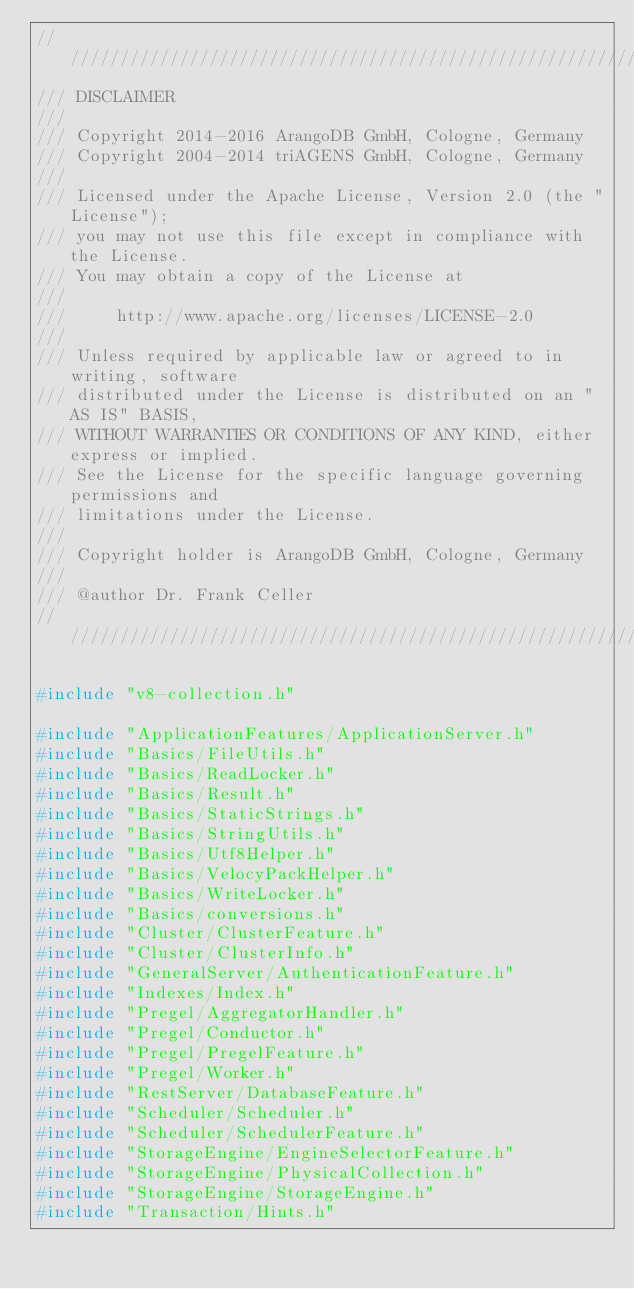<code> <loc_0><loc_0><loc_500><loc_500><_C++_>////////////////////////////////////////////////////////////////////////////////
/// DISCLAIMER
///
/// Copyright 2014-2016 ArangoDB GmbH, Cologne, Germany
/// Copyright 2004-2014 triAGENS GmbH, Cologne, Germany
///
/// Licensed under the Apache License, Version 2.0 (the "License");
/// you may not use this file except in compliance with the License.
/// You may obtain a copy of the License at
///
///     http://www.apache.org/licenses/LICENSE-2.0
///
/// Unless required by applicable law or agreed to in writing, software
/// distributed under the License is distributed on an "AS IS" BASIS,
/// WITHOUT WARRANTIES OR CONDITIONS OF ANY KIND, either express or implied.
/// See the License for the specific language governing permissions and
/// limitations under the License.
///
/// Copyright holder is ArangoDB GmbH, Cologne, Germany
///
/// @author Dr. Frank Celler
////////////////////////////////////////////////////////////////////////////////

#include "v8-collection.h"

#include "ApplicationFeatures/ApplicationServer.h"
#include "Basics/FileUtils.h"
#include "Basics/ReadLocker.h"
#include "Basics/Result.h"
#include "Basics/StaticStrings.h"
#include "Basics/StringUtils.h"
#include "Basics/Utf8Helper.h"
#include "Basics/VelocyPackHelper.h"
#include "Basics/WriteLocker.h"
#include "Basics/conversions.h"
#include "Cluster/ClusterFeature.h"
#include "Cluster/ClusterInfo.h"
#include "GeneralServer/AuthenticationFeature.h"
#include "Indexes/Index.h"
#include "Pregel/AggregatorHandler.h"
#include "Pregel/Conductor.h"
#include "Pregel/PregelFeature.h"
#include "Pregel/Worker.h"
#include "RestServer/DatabaseFeature.h"
#include "Scheduler/Scheduler.h"
#include "Scheduler/SchedulerFeature.h"
#include "StorageEngine/EngineSelectorFeature.h"
#include "StorageEngine/PhysicalCollection.h"
#include "StorageEngine/StorageEngine.h"
#include "Transaction/Hints.h"</code> 